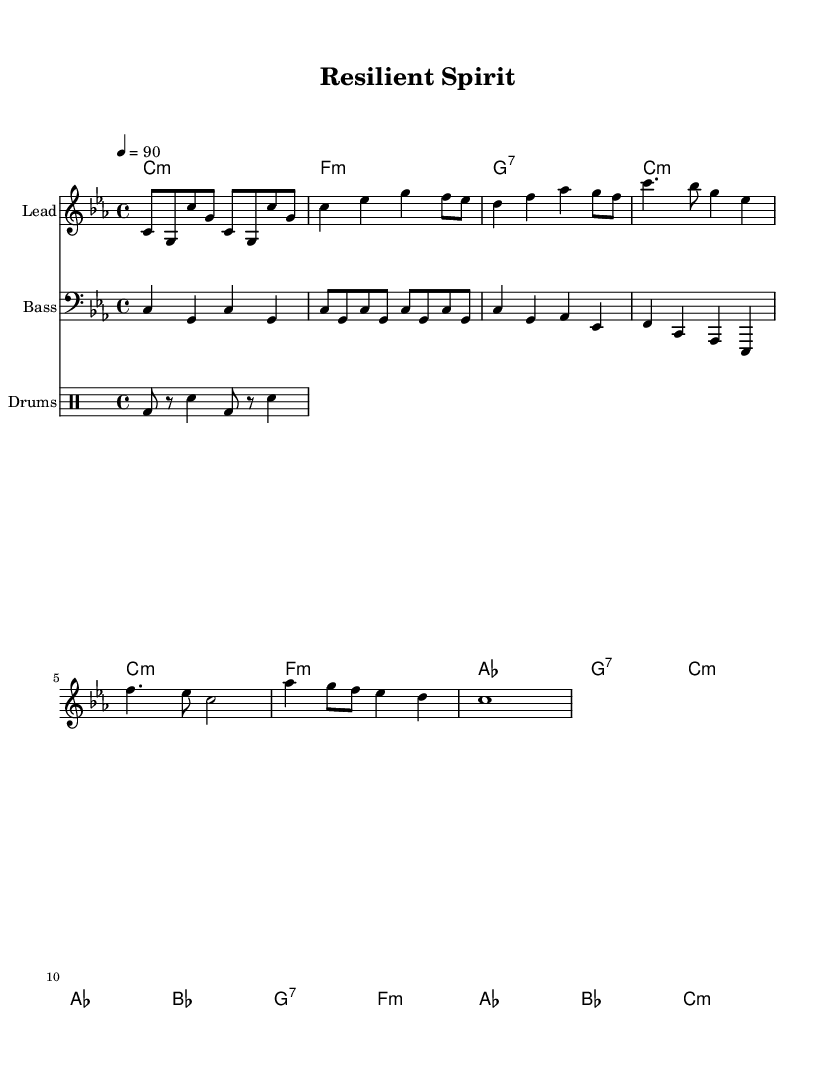What is the key signature of this music? The key signature is C minor, which has three flats: B flat, E flat, and A flat.
Answer: C minor What is the time signature of the piece? The time signature, indicated at the beginning of the sheet music, is 4/4. This means there are four beats in each measure, and the quarter note gets one beat.
Answer: 4/4 What is the tempo marking indicated in the score? The tempo marking is written as 4 = 90, which means that there are 90 beats per minute. The "4" indicates the quarter note as the beat unit.
Answer: 90 How many measures are in the Verse section? The Verse consists of 8 measures, as indicated by the notation provided under the melody section. This can be counted by looking at the bar lines separating the measures.
Answer: 8 How many different sections are there in the composition? The composition contains four distinct sections: Intro, Verse, Chorus, and Bridge. Each section has a unique role in the flow of the music.
Answer: 4 What type of vocal technique is indicated by the lyrics under the melody? The lyrics suggest a spoken word or rhythmic style typical of rap, with an emphasis on flow and delivery, represented throughout the melodic structure.
Answer: Rap What is the overall mood conveyed through the lyrics and music? The music and lyrics convey a sense of resilience and perseverance, encouraging listeners to find strength in adversity and engage in self-care techniques.
Answer: Uplifting 